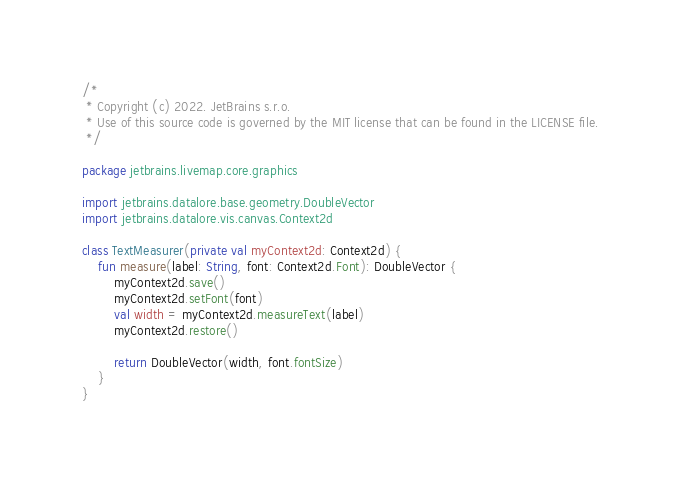<code> <loc_0><loc_0><loc_500><loc_500><_Kotlin_>/*
 * Copyright (c) 2022. JetBrains s.r.o.
 * Use of this source code is governed by the MIT license that can be found in the LICENSE file.
 */

package jetbrains.livemap.core.graphics

import jetbrains.datalore.base.geometry.DoubleVector
import jetbrains.datalore.vis.canvas.Context2d

class TextMeasurer(private val myContext2d: Context2d) {
    fun measure(label: String, font: Context2d.Font): DoubleVector {
        myContext2d.save()
        myContext2d.setFont(font)
        val width = myContext2d.measureText(label)
        myContext2d.restore()

        return DoubleVector(width, font.fontSize)
    }
}</code> 